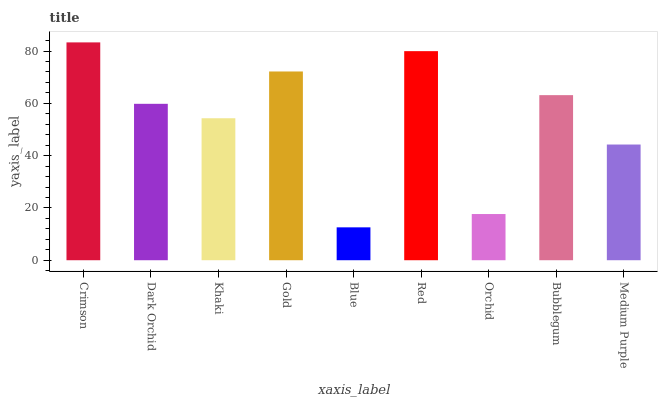Is Blue the minimum?
Answer yes or no. Yes. Is Crimson the maximum?
Answer yes or no. Yes. Is Dark Orchid the minimum?
Answer yes or no. No. Is Dark Orchid the maximum?
Answer yes or no. No. Is Crimson greater than Dark Orchid?
Answer yes or no. Yes. Is Dark Orchid less than Crimson?
Answer yes or no. Yes. Is Dark Orchid greater than Crimson?
Answer yes or no. No. Is Crimson less than Dark Orchid?
Answer yes or no. No. Is Dark Orchid the high median?
Answer yes or no. Yes. Is Dark Orchid the low median?
Answer yes or no. Yes. Is Khaki the high median?
Answer yes or no. No. Is Medium Purple the low median?
Answer yes or no. No. 